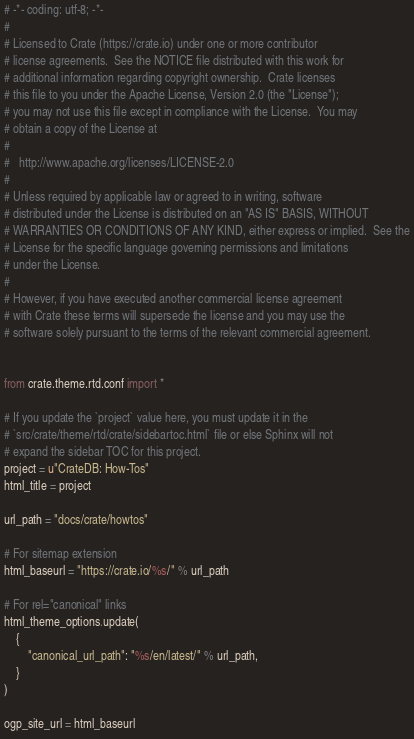<code> <loc_0><loc_0><loc_500><loc_500><_Python_># -*- coding: utf-8; -*-
#
# Licensed to Crate (https://crate.io) under one or more contributor
# license agreements.  See the NOTICE file distributed with this work for
# additional information regarding copyright ownership.  Crate licenses
# this file to you under the Apache License, Version 2.0 (the "License");
# you may not use this file except in compliance with the License.  You may
# obtain a copy of the License at
#
#   http://www.apache.org/licenses/LICENSE-2.0
#
# Unless required by applicable law or agreed to in writing, software
# distributed under the License is distributed on an "AS IS" BASIS, WITHOUT
# WARRANTIES OR CONDITIONS OF ANY KIND, either express or implied.  See the
# License for the specific language governing permissions and limitations
# under the License.
#
# However, if you have executed another commercial license agreement
# with Crate these terms will supersede the license and you may use the
# software solely pursuant to the terms of the relevant commercial agreement.


from crate.theme.rtd.conf import *

# If you update the `project` value here, you must update it in the
# `src/crate/theme/rtd/crate/sidebartoc.html` file or else Sphinx will not
# expand the sidebar TOC for this project.
project = u"CrateDB: How-Tos"
html_title = project

url_path = "docs/crate/howtos"

# For sitemap extension
html_baseurl = "https://crate.io/%s/" % url_path

# For rel="canonical" links
html_theme_options.update(
    {
        "canonical_url_path": "%s/en/latest/" % url_path,
    }
)

ogp_site_url = html_baseurl
</code> 